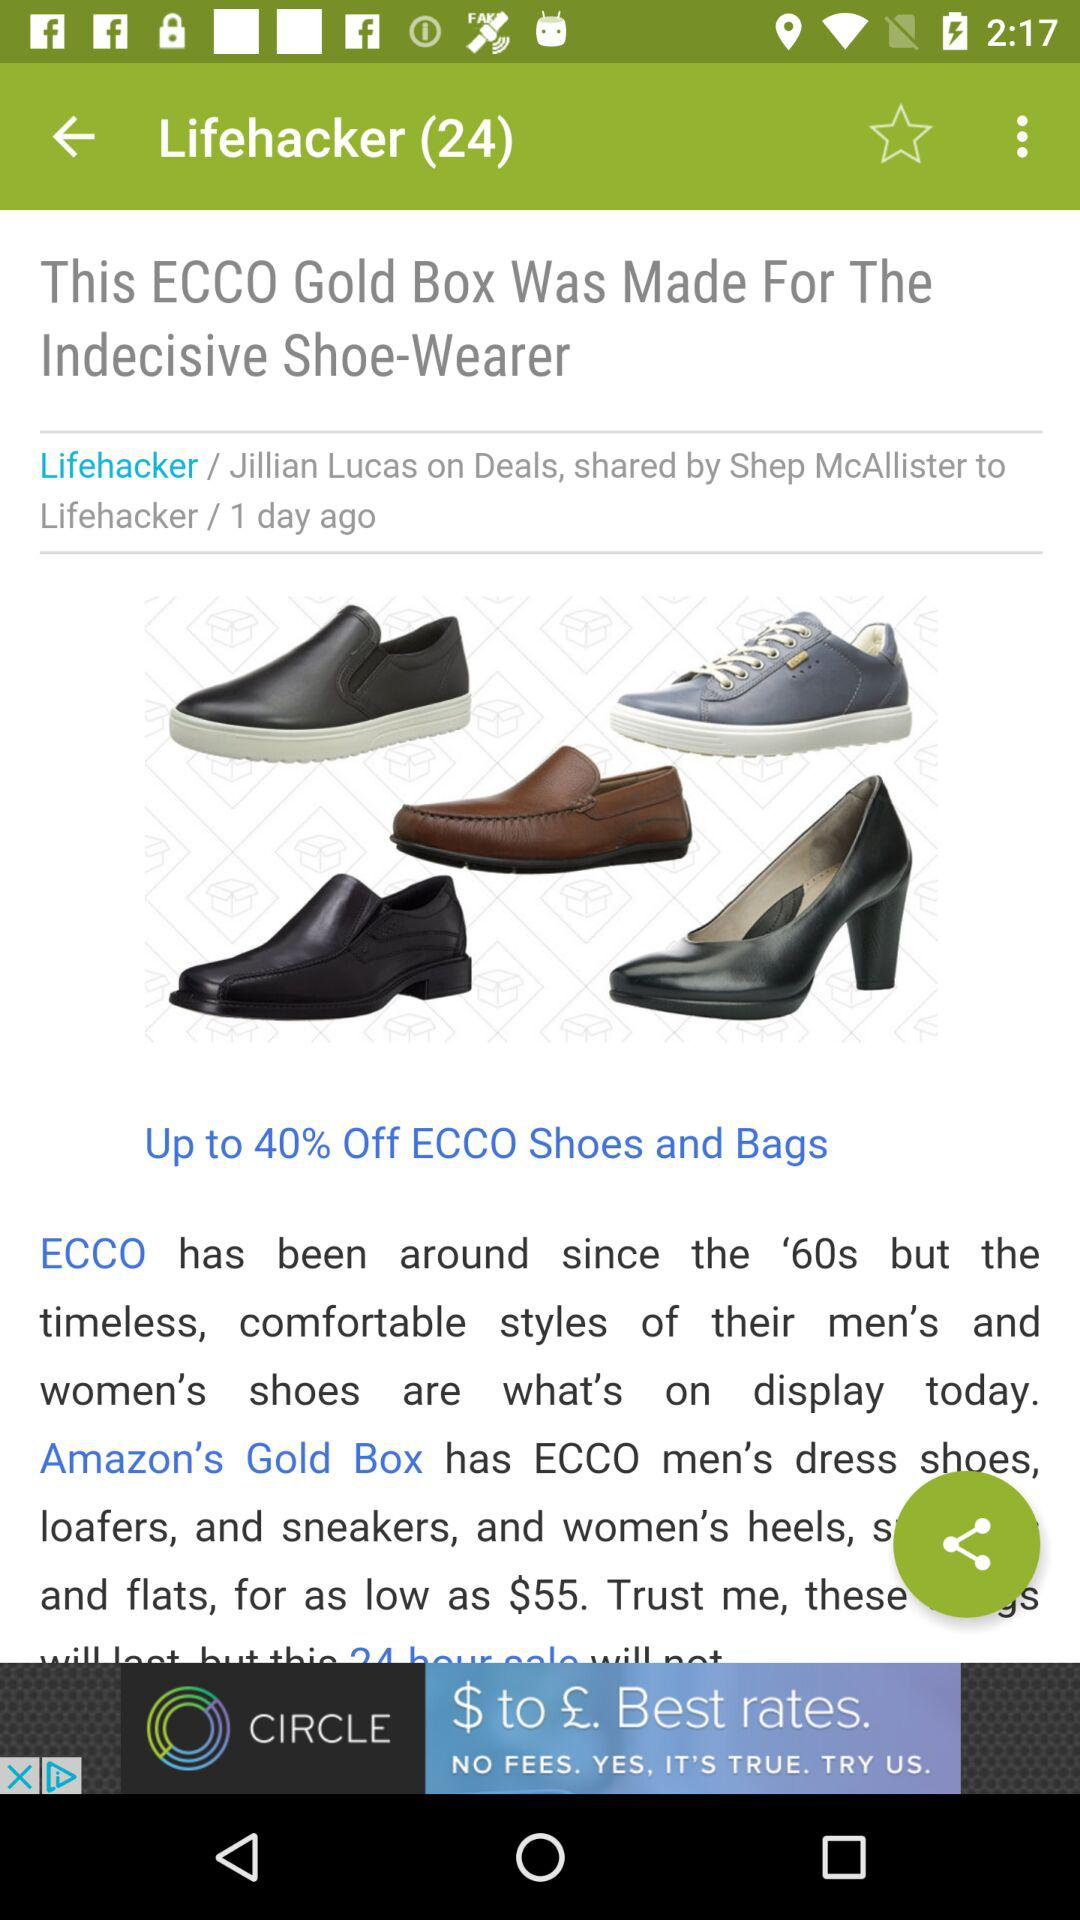What is the application name? The application name is "Lifehacker". 